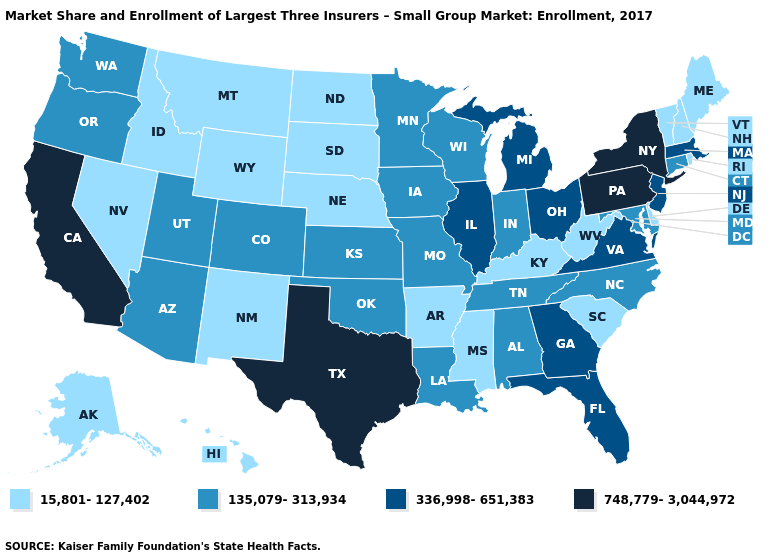Does Georgia have the lowest value in the USA?
Short answer required. No. What is the value of New Jersey?
Write a very short answer. 336,998-651,383. What is the value of Rhode Island?
Be succinct. 15,801-127,402. Which states hav the highest value in the South?
Short answer required. Texas. What is the lowest value in the MidWest?
Short answer required. 15,801-127,402. What is the lowest value in states that border Louisiana?
Concise answer only. 15,801-127,402. Does Idaho have the lowest value in the USA?
Concise answer only. Yes. Name the states that have a value in the range 748,779-3,044,972?
Quick response, please. California, New York, Pennsylvania, Texas. Does Georgia have the same value as Virginia?
Answer briefly. Yes. Among the states that border New Hampshire , does Massachusetts have the lowest value?
Quick response, please. No. Name the states that have a value in the range 135,079-313,934?
Write a very short answer. Alabama, Arizona, Colorado, Connecticut, Indiana, Iowa, Kansas, Louisiana, Maryland, Minnesota, Missouri, North Carolina, Oklahoma, Oregon, Tennessee, Utah, Washington, Wisconsin. Name the states that have a value in the range 15,801-127,402?
Short answer required. Alaska, Arkansas, Delaware, Hawaii, Idaho, Kentucky, Maine, Mississippi, Montana, Nebraska, Nevada, New Hampshire, New Mexico, North Dakota, Rhode Island, South Carolina, South Dakota, Vermont, West Virginia, Wyoming. What is the value of Iowa?
Short answer required. 135,079-313,934. Does Ohio have the highest value in the MidWest?
Answer briefly. Yes. What is the lowest value in states that border Nevada?
Short answer required. 15,801-127,402. 